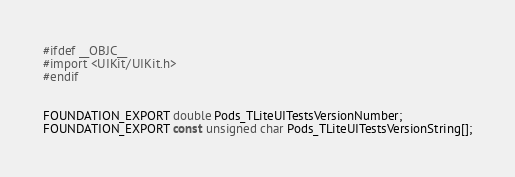Convert code to text. <code><loc_0><loc_0><loc_500><loc_500><_C_>#ifdef __OBJC__
#import <UIKit/UIKit.h>
#endif


FOUNDATION_EXPORT double Pods_TLiteUITestsVersionNumber;
FOUNDATION_EXPORT const unsigned char Pods_TLiteUITestsVersionString[];

</code> 